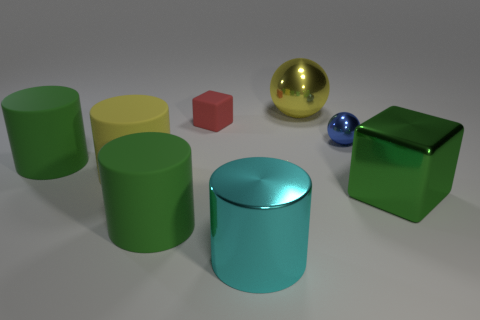There is another object that is the same shape as the tiny blue thing; what is its color?
Keep it short and to the point. Yellow. Are there any large metallic things that have the same shape as the red matte thing?
Keep it short and to the point. Yes. What is the shape of the big metal thing that is in front of the big green block in front of the tiny matte block?
Give a very brief answer. Cylinder. What number of cubes are red objects or large green shiny things?
Your response must be concise. 2. There is a matte object that is in front of the green cube; is its shape the same as the big yellow thing that is in front of the large yellow metal sphere?
Your response must be concise. Yes. There is a big thing that is on the left side of the small blue thing and on the right side of the cyan metallic thing; what color is it?
Your response must be concise. Yellow. Is the color of the big block the same as the large rubber object in front of the big green cube?
Make the answer very short. Yes. What is the size of the thing that is both on the left side of the small matte object and to the right of the large yellow matte thing?
Offer a very short reply. Large. What number of other objects are there of the same color as the tiny sphere?
Give a very brief answer. 0. There is a green rubber thing in front of the metallic cube to the right of the matte cube that is in front of the large ball; what is its size?
Provide a succinct answer. Large. 